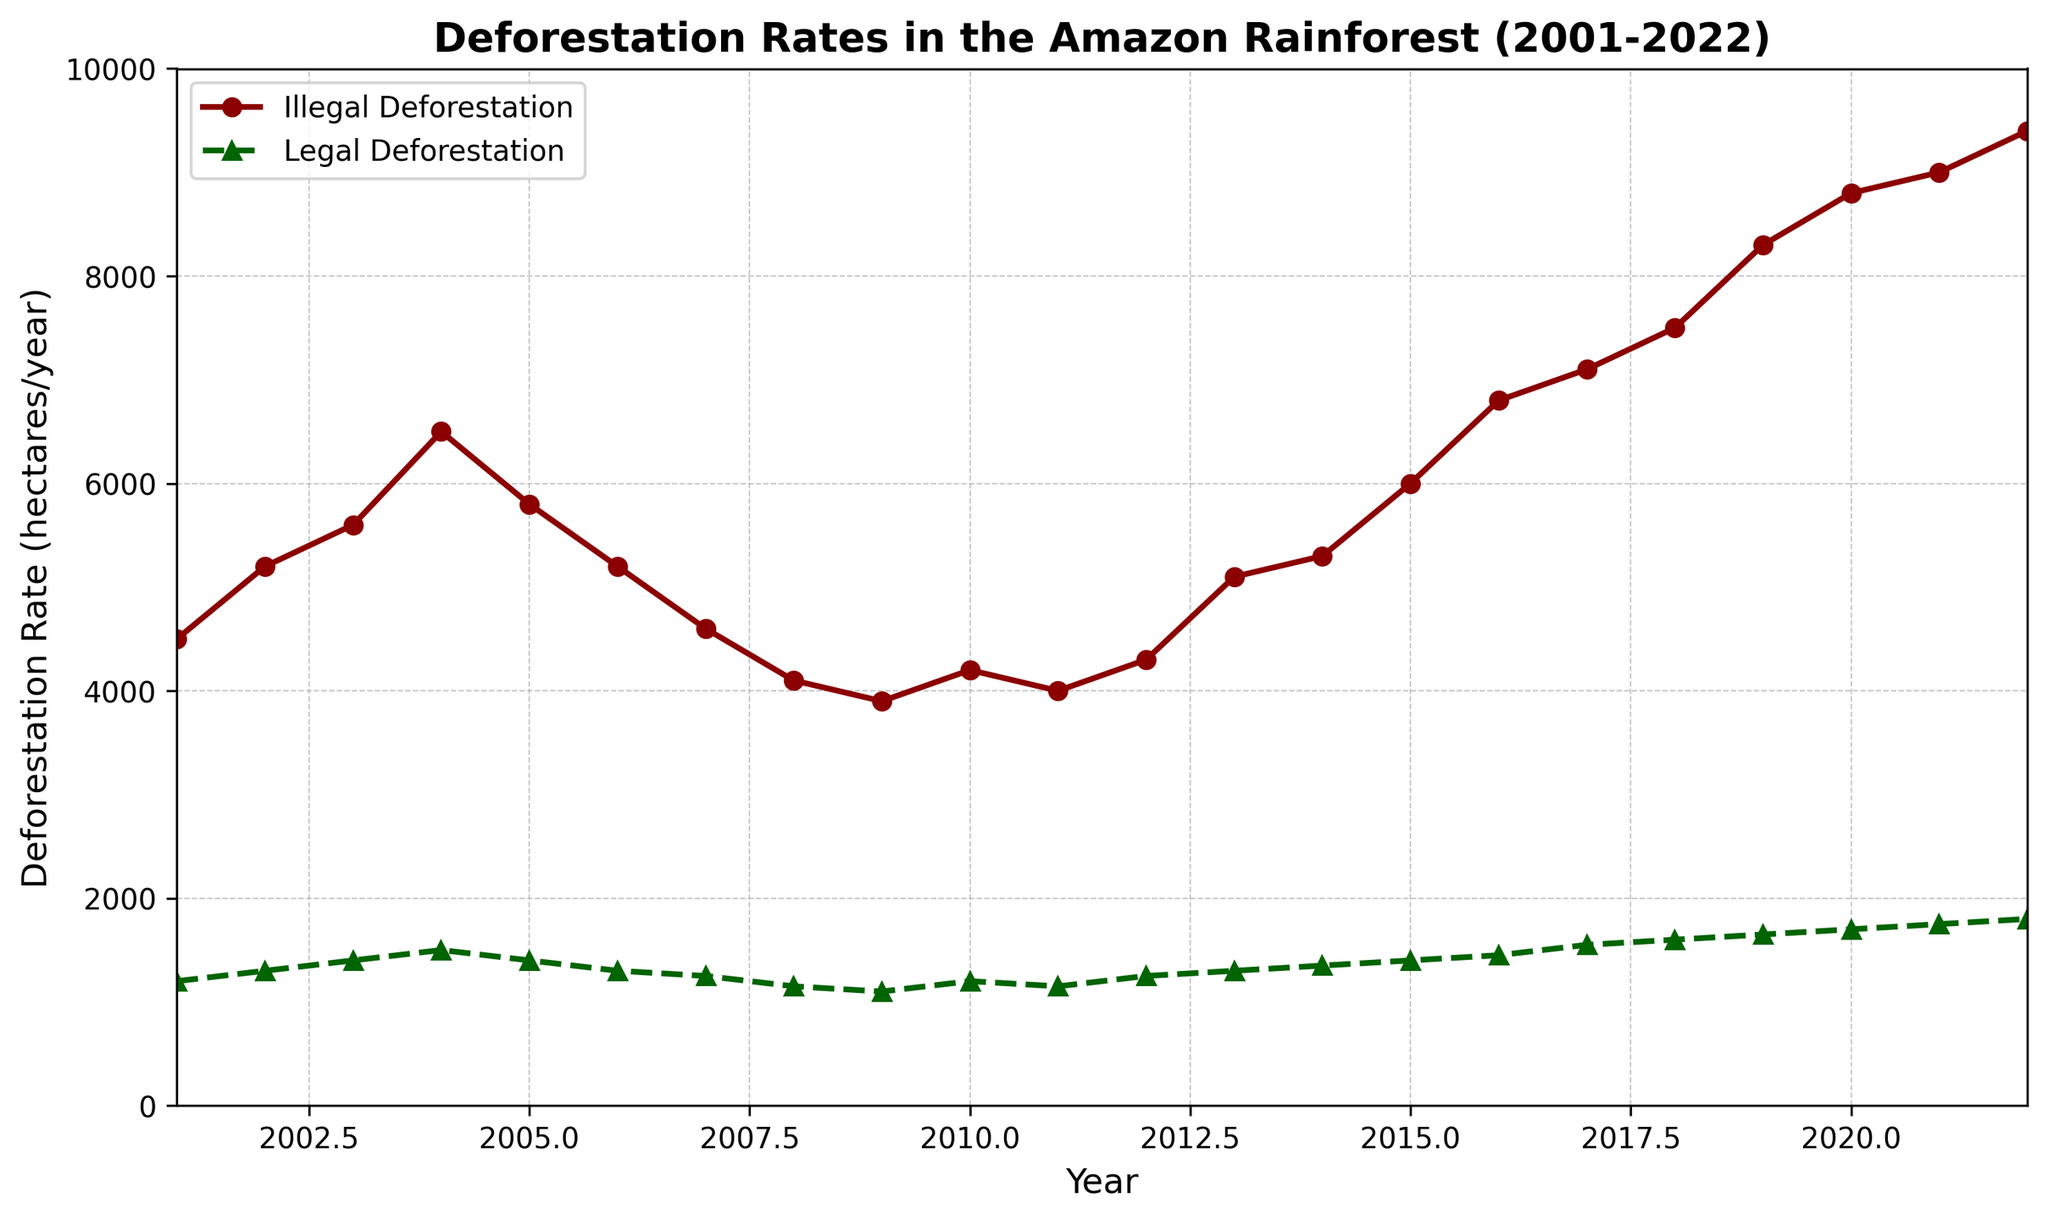What year had the highest rate of illegal deforestation? To find the year with the highest rate of illegal deforestation, locate the peak of the dark red line. The highest point is on the year 2022.
Answer: 2022 What is the difference in deforestation rates between illegal and legal activities in 2010? Observe the values for both illegal (4200) and legal (1200) deforestation rates in 2010, then subtract the legal rate from the illegal rate: 4200 - 1200 = 3000.
Answer: 3000 In which years did the illegal deforestation rate decrease compared to the previous year? Scan the dark red line to identify years where there's a decline compared to the previous year. These years are 2005, 2006, 2008, and 2009.
Answer: 2005, 2006, 2008, 2009 What is the average illegal deforestation rate over the period 2016 to 2022? Calculate the sum of the rates from 2016 to 2022 (6800 + 7100 + 7500 + 8300 + 8800 + 9000 + 9400 = 56900) and divide by the number of years (7): 56900 / 7 ≈ 8130.
Answer: 8130 Which year had the smallest difference between illegal and legal deforestation rates? Compare the differences for each year by subtracting legal rates from illegal rates, and find the smallest difference. The smallest difference occurs in 2007 (4600 - 1250 = 3350).
Answer: 2007 How did the rate of legal deforestation change from 2001 to 2022? Review the green dashed line from its starting point in 2001 to its end point in 2022. The rate increased from 1200 to 1800, indicating an overall rise.
Answer: Increased What is the visual difference between the lines representing illegal and legal deforestation rates? The illegal deforestation rate is shown by a dark red solid line with circle markers, while the legal deforestation rate is indicated by a dark green dashed line with triangle markers.
Answer: Dark red solid line with circles vs. dark green dashed line with triangles By what factor did the illegal deforestation rate increase from 2001 to 2022? Divide the illegal deforestation rate in 2022 (9400) by the rate in 2001 (4500): 9400 / 4500 ≈ 2.09.
Answer: 2.09 What is the total combined deforestation rate (illegal + legal) in the year 2015? Add the rates of illegal (6000) and legal (1400) deforestation for 2015: 6000 + 1400 = 7400.
Answer: 7400 